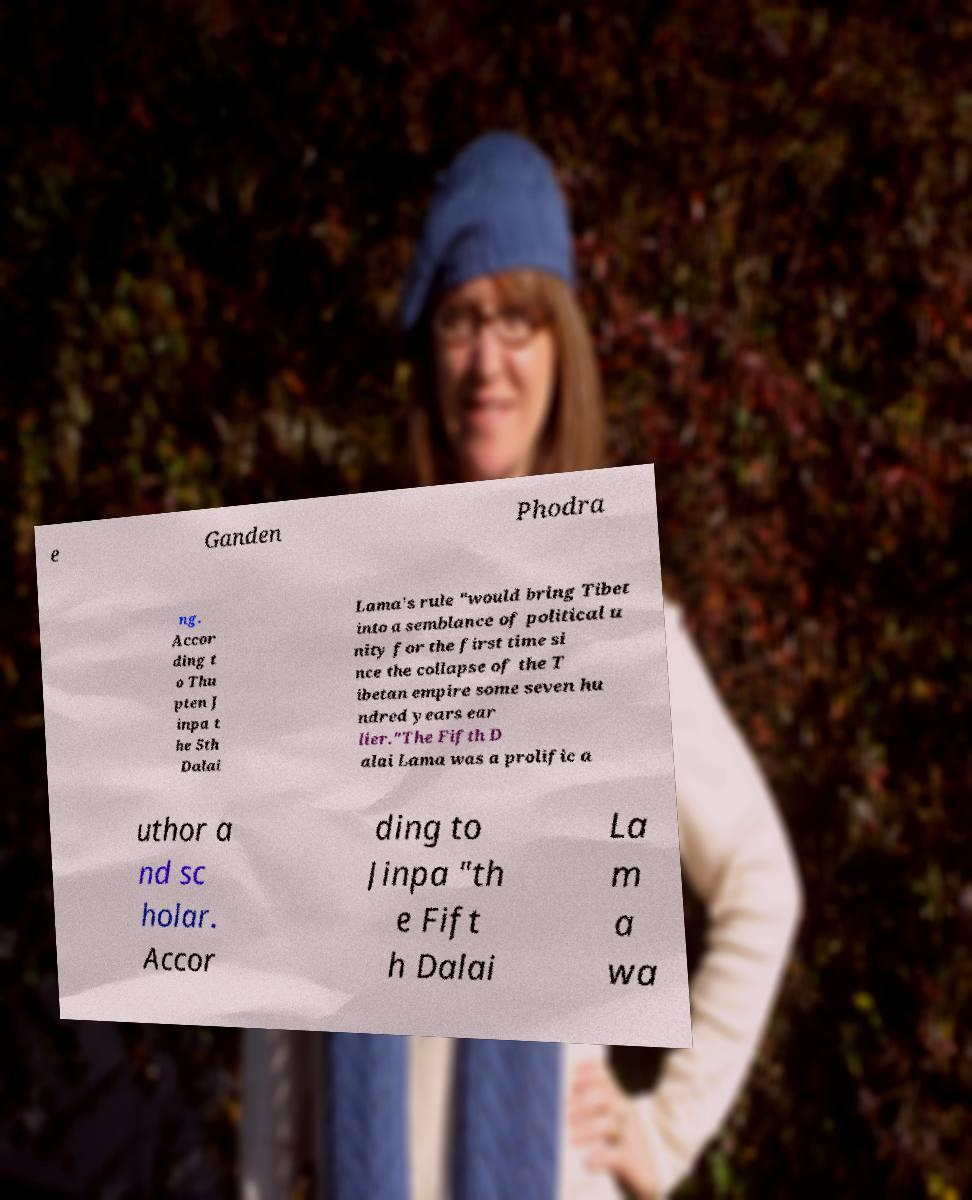There's text embedded in this image that I need extracted. Can you transcribe it verbatim? e Ganden Phodra ng. Accor ding t o Thu pten J inpa t he 5th Dalai Lama's rule "would bring Tibet into a semblance of political u nity for the first time si nce the collapse of the T ibetan empire some seven hu ndred years ear lier."The Fifth D alai Lama was a prolific a uthor a nd sc holar. Accor ding to Jinpa "th e Fift h Dalai La m a wa 